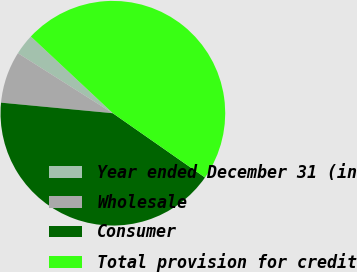Convert chart to OTSL. <chart><loc_0><loc_0><loc_500><loc_500><pie_chart><fcel>Year ended December 31 (in<fcel>Wholesale<fcel>Consumer<fcel>Total provision for credit<nl><fcel>3.0%<fcel>7.47%<fcel>41.81%<fcel>47.73%<nl></chart> 